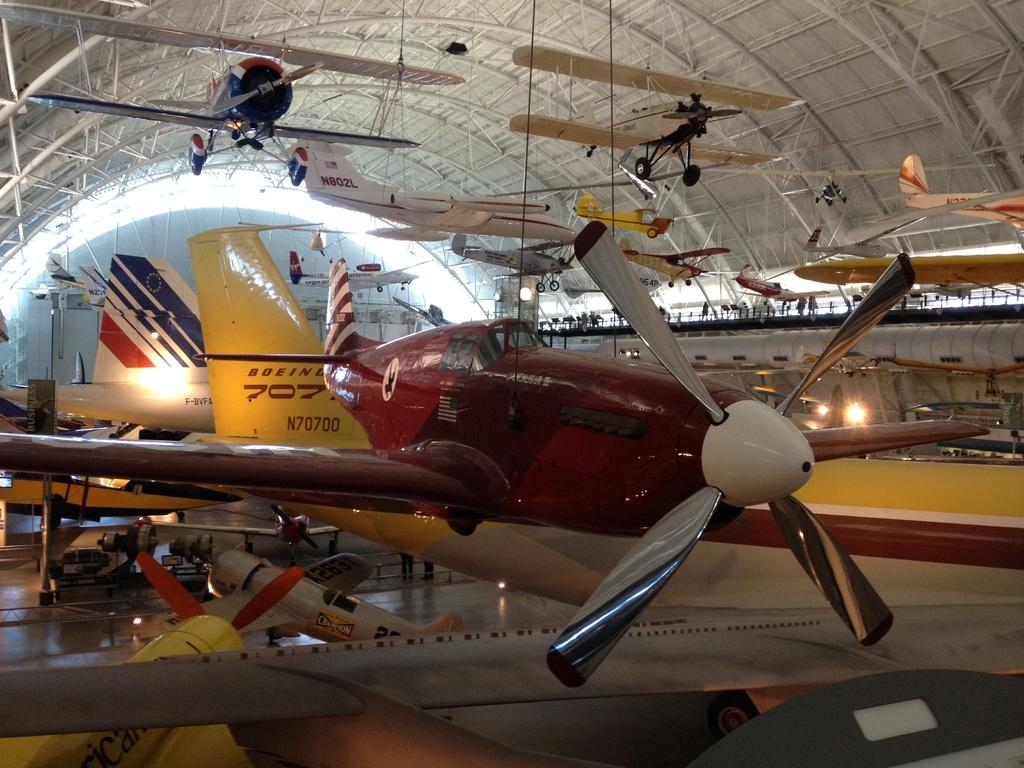What is the main subject of the image? The main subject of the image is an aeroplane. Can you describe the color of the aeroplane? The aeroplane is in dark red color. Are there any other aeroplanes in the image? Yes, there is another aeroplane in the image. What is the color of the second aeroplane? The second aeroplane is in white color. What other structure can be seen in the image? There is an iron shed in the image. Where is the iron shed located in the image? The iron shed is at the top of the image. What type of underwear is hanging on the iron shed in the image? There is no underwear present in the image; it only features aeroplanes and an iron shed. 